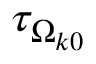Convert formula to latex. <formula><loc_0><loc_0><loc_500><loc_500>\tau _ { \Omega _ { k 0 } }</formula> 